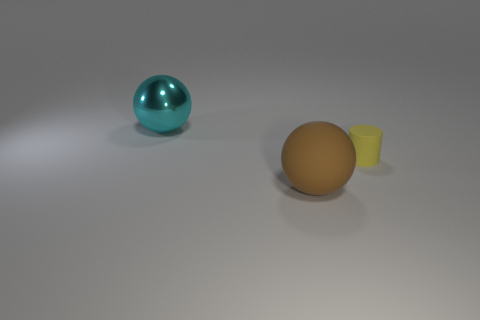Add 1 cyan shiny objects. How many objects exist? 4 Subtract 0 purple cylinders. How many objects are left? 3 Subtract all cylinders. How many objects are left? 2 Subtract all green cylinders. Subtract all blue blocks. How many cylinders are left? 1 Subtract all big metal objects. Subtract all large rubber spheres. How many objects are left? 1 Add 3 large rubber things. How many large rubber things are left? 4 Add 1 small brown matte cylinders. How many small brown matte cylinders exist? 1 